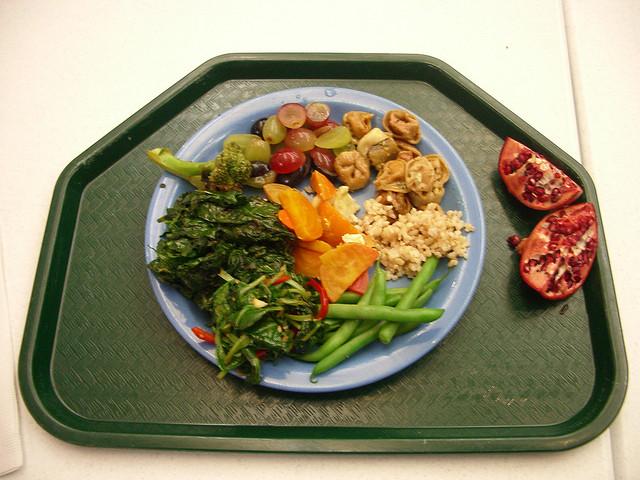What is green?
Quick response, please. Beans and spinach. What type of fruit is on the tray?
Write a very short answer. Pomegranate. Is this from Mcdonalds?
Answer briefly. No. What food is on lower left?
Write a very short answer. Spinach. 